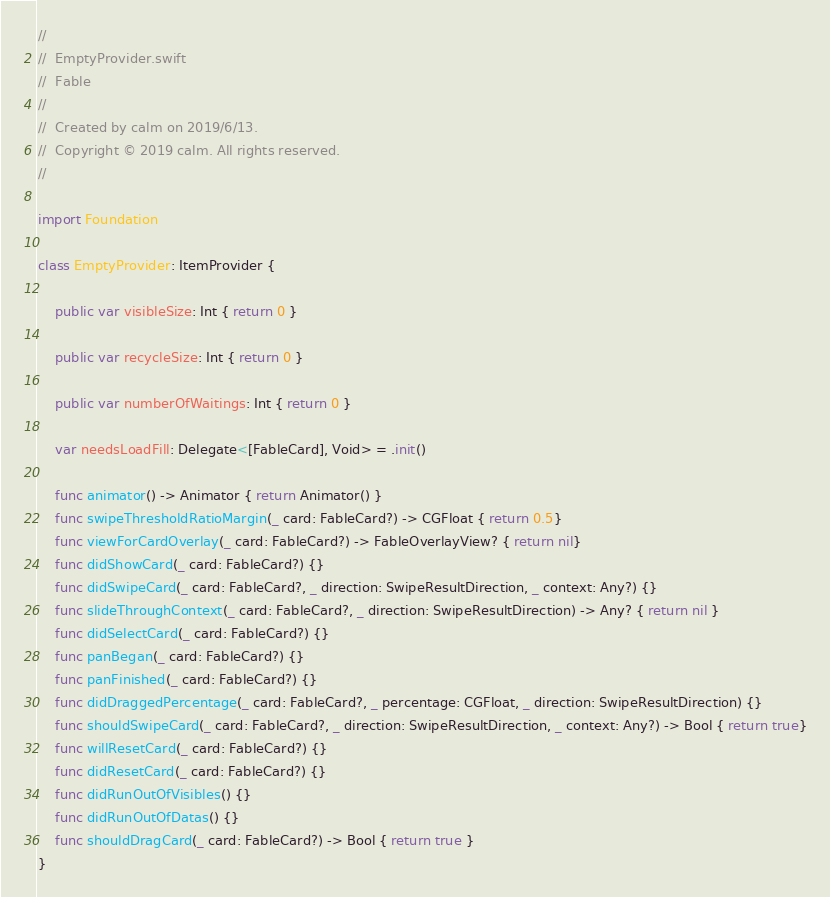<code> <loc_0><loc_0><loc_500><loc_500><_Swift_>//
//  EmptyProvider.swift
//  Fable
//
//  Created by calm on 2019/6/13.
//  Copyright © 2019 calm. All rights reserved.
//

import Foundation

class EmptyProvider: ItemProvider {
    
    public var visibleSize: Int { return 0 }
    
    public var recycleSize: Int { return 0 }
    
    public var numberOfWaitings: Int { return 0 }
    
    var needsLoadFill: Delegate<[FableCard], Void> = .init()
    
    func animator() -> Animator { return Animator() }
    func swipeThresholdRatioMargin(_ card: FableCard?) -> CGFloat { return 0.5}
    func viewForCardOverlay(_ card: FableCard?) -> FableOverlayView? { return nil}
    func didShowCard(_ card: FableCard?) {}
    func didSwipeCard(_ card: FableCard?, _ direction: SwipeResultDirection, _ context: Any?) {}
    func slideThroughContext(_ card: FableCard?, _ direction: SwipeResultDirection) -> Any? { return nil }
    func didSelectCard(_ card: FableCard?) {}
    func panBegan(_ card: FableCard?) {}
    func panFinished(_ card: FableCard?) {}
    func didDraggedPercentage(_ card: FableCard?, _ percentage: CGFloat, _ direction: SwipeResultDirection) {}
    func shouldSwipeCard(_ card: FableCard?, _ direction: SwipeResultDirection, _ context: Any?) -> Bool { return true}
    func willResetCard(_ card: FableCard?) {}
    func didResetCard(_ card: FableCard?) {}
    func didRunOutOfVisibles() {}
    func didRunOutOfDatas() {}
    func shouldDragCard(_ card: FableCard?) -> Bool { return true }
}
</code> 